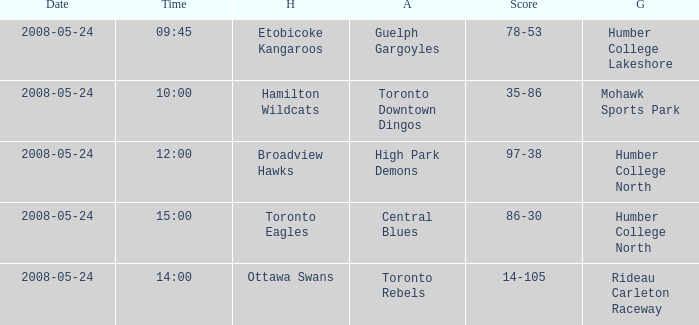On what day was the game that ended in a score of 97-38? 2008-05-24. 